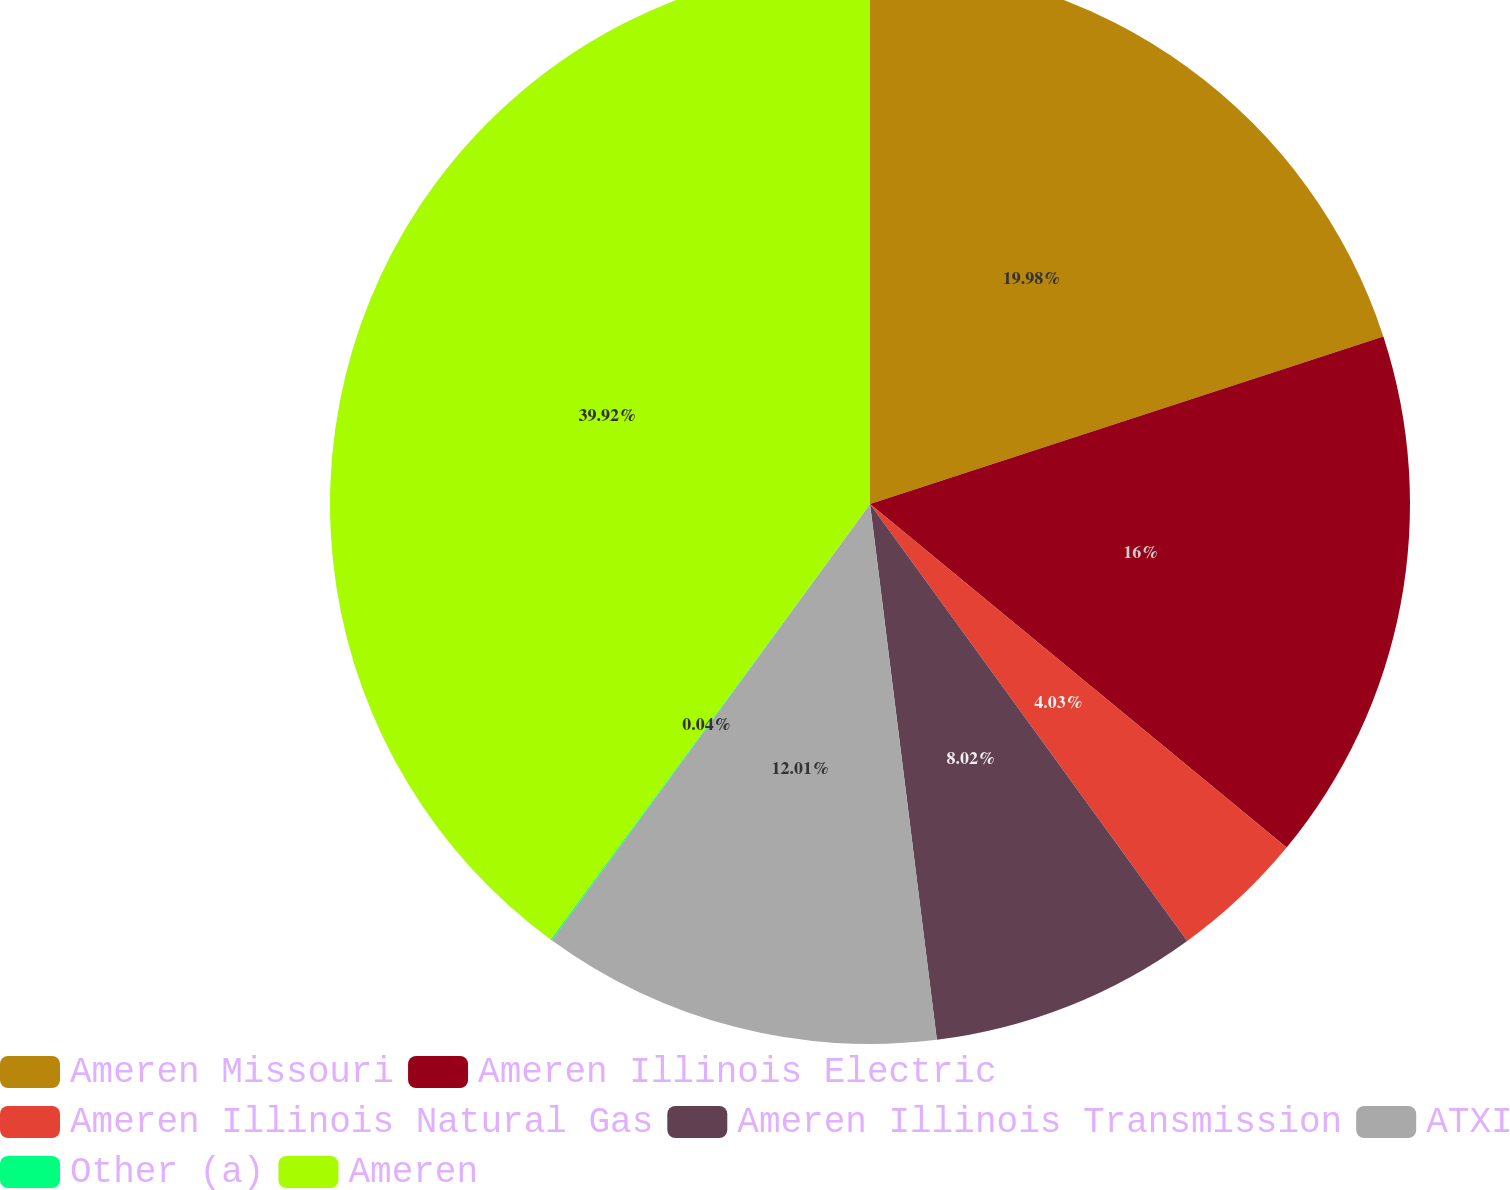Convert chart. <chart><loc_0><loc_0><loc_500><loc_500><pie_chart><fcel>Ameren Missouri<fcel>Ameren Illinois Electric<fcel>Ameren Illinois Natural Gas<fcel>Ameren Illinois Transmission<fcel>ATXI<fcel>Other (a)<fcel>Ameren<nl><fcel>19.98%<fcel>16.0%<fcel>4.03%<fcel>8.02%<fcel>12.01%<fcel>0.04%<fcel>39.93%<nl></chart> 